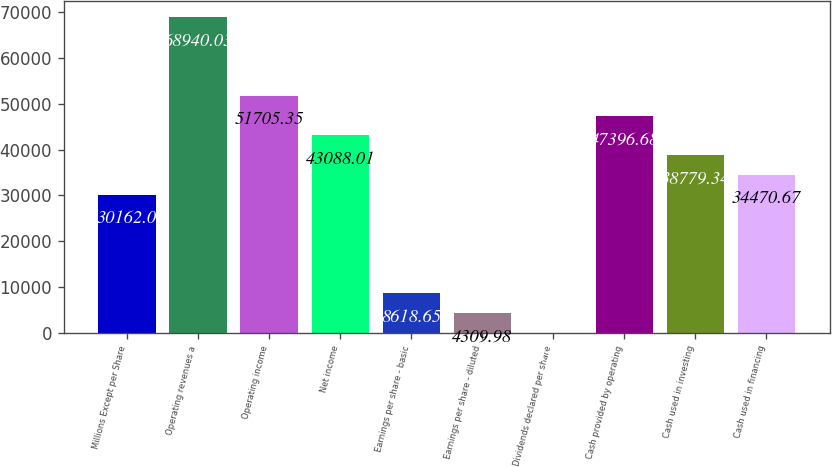Convert chart. <chart><loc_0><loc_0><loc_500><loc_500><bar_chart><fcel>Millions Except per Share<fcel>Operating revenues a<fcel>Operating income<fcel>Net income<fcel>Earnings per share - basic<fcel>Earnings per share - diluted<fcel>Dividends declared per share<fcel>Cash provided by operating<fcel>Cash used in investing<fcel>Cash used in financing<nl><fcel>30162<fcel>68940<fcel>51705.3<fcel>43088<fcel>8618.65<fcel>4309.98<fcel>1.31<fcel>47396.7<fcel>38779.3<fcel>34470.7<nl></chart> 